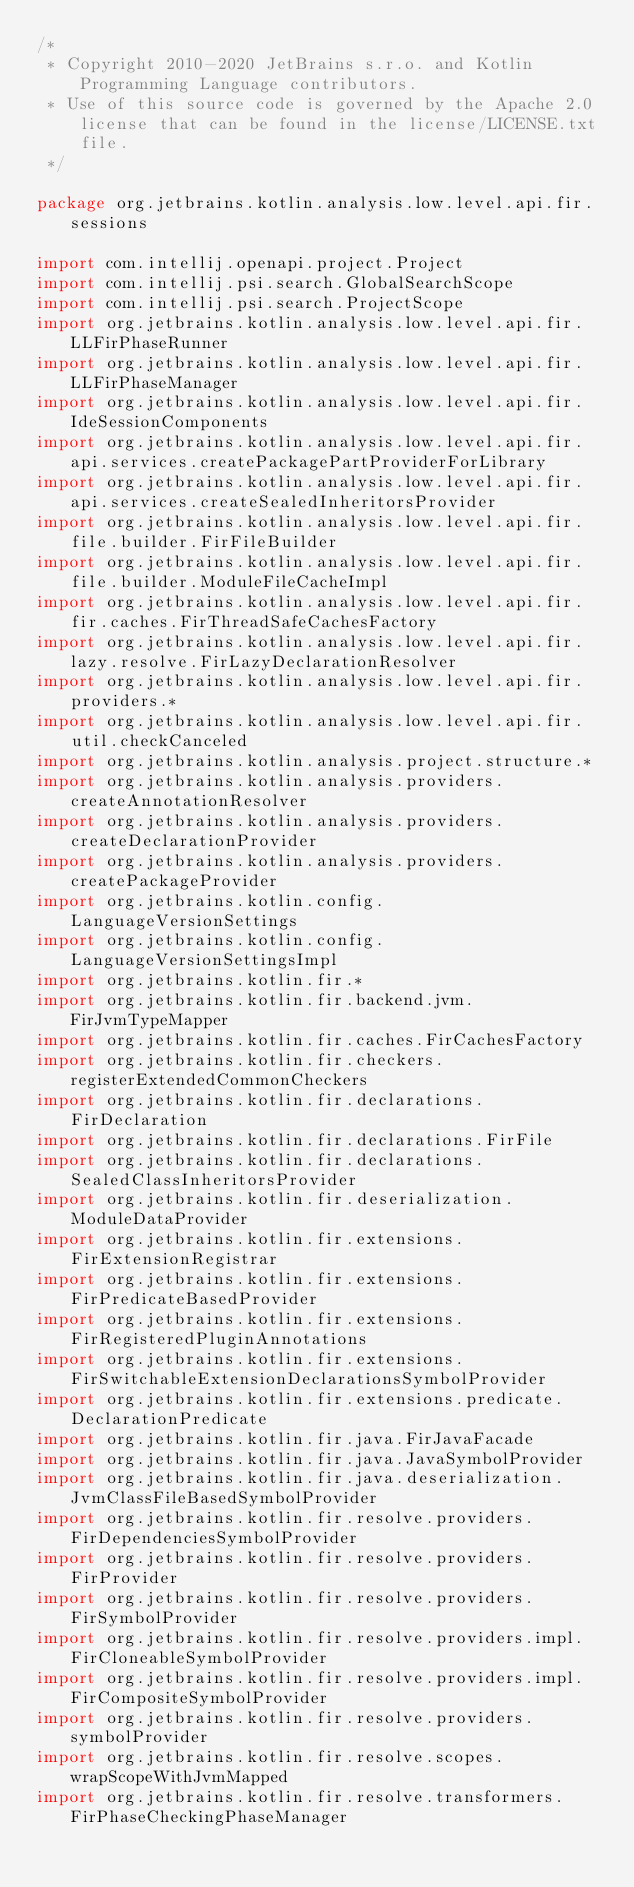Convert code to text. <code><loc_0><loc_0><loc_500><loc_500><_Kotlin_>/*
 * Copyright 2010-2020 JetBrains s.r.o. and Kotlin Programming Language contributors.
 * Use of this source code is governed by the Apache 2.0 license that can be found in the license/LICENSE.txt file.
 */

package org.jetbrains.kotlin.analysis.low.level.api.fir.sessions

import com.intellij.openapi.project.Project
import com.intellij.psi.search.GlobalSearchScope
import com.intellij.psi.search.ProjectScope
import org.jetbrains.kotlin.analysis.low.level.api.fir.LLFirPhaseRunner
import org.jetbrains.kotlin.analysis.low.level.api.fir.LLFirPhaseManager
import org.jetbrains.kotlin.analysis.low.level.api.fir.IdeSessionComponents
import org.jetbrains.kotlin.analysis.low.level.api.fir.api.services.createPackagePartProviderForLibrary
import org.jetbrains.kotlin.analysis.low.level.api.fir.api.services.createSealedInheritorsProvider
import org.jetbrains.kotlin.analysis.low.level.api.fir.file.builder.FirFileBuilder
import org.jetbrains.kotlin.analysis.low.level.api.fir.file.builder.ModuleFileCacheImpl
import org.jetbrains.kotlin.analysis.low.level.api.fir.fir.caches.FirThreadSafeCachesFactory
import org.jetbrains.kotlin.analysis.low.level.api.fir.lazy.resolve.FirLazyDeclarationResolver
import org.jetbrains.kotlin.analysis.low.level.api.fir.providers.*
import org.jetbrains.kotlin.analysis.low.level.api.fir.util.checkCanceled
import org.jetbrains.kotlin.analysis.project.structure.*
import org.jetbrains.kotlin.analysis.providers.createAnnotationResolver
import org.jetbrains.kotlin.analysis.providers.createDeclarationProvider
import org.jetbrains.kotlin.analysis.providers.createPackageProvider
import org.jetbrains.kotlin.config.LanguageVersionSettings
import org.jetbrains.kotlin.config.LanguageVersionSettingsImpl
import org.jetbrains.kotlin.fir.*
import org.jetbrains.kotlin.fir.backend.jvm.FirJvmTypeMapper
import org.jetbrains.kotlin.fir.caches.FirCachesFactory
import org.jetbrains.kotlin.fir.checkers.registerExtendedCommonCheckers
import org.jetbrains.kotlin.fir.declarations.FirDeclaration
import org.jetbrains.kotlin.fir.declarations.FirFile
import org.jetbrains.kotlin.fir.declarations.SealedClassInheritorsProvider
import org.jetbrains.kotlin.fir.deserialization.ModuleDataProvider
import org.jetbrains.kotlin.fir.extensions.FirExtensionRegistrar
import org.jetbrains.kotlin.fir.extensions.FirPredicateBasedProvider
import org.jetbrains.kotlin.fir.extensions.FirRegisteredPluginAnnotations
import org.jetbrains.kotlin.fir.extensions.FirSwitchableExtensionDeclarationsSymbolProvider
import org.jetbrains.kotlin.fir.extensions.predicate.DeclarationPredicate
import org.jetbrains.kotlin.fir.java.FirJavaFacade
import org.jetbrains.kotlin.fir.java.JavaSymbolProvider
import org.jetbrains.kotlin.fir.java.deserialization.JvmClassFileBasedSymbolProvider
import org.jetbrains.kotlin.fir.resolve.providers.FirDependenciesSymbolProvider
import org.jetbrains.kotlin.fir.resolve.providers.FirProvider
import org.jetbrains.kotlin.fir.resolve.providers.FirSymbolProvider
import org.jetbrains.kotlin.fir.resolve.providers.impl.FirCloneableSymbolProvider
import org.jetbrains.kotlin.fir.resolve.providers.impl.FirCompositeSymbolProvider
import org.jetbrains.kotlin.fir.resolve.providers.symbolProvider
import org.jetbrains.kotlin.fir.resolve.scopes.wrapScopeWithJvmMapped
import org.jetbrains.kotlin.fir.resolve.transformers.FirPhaseCheckingPhaseManager</code> 